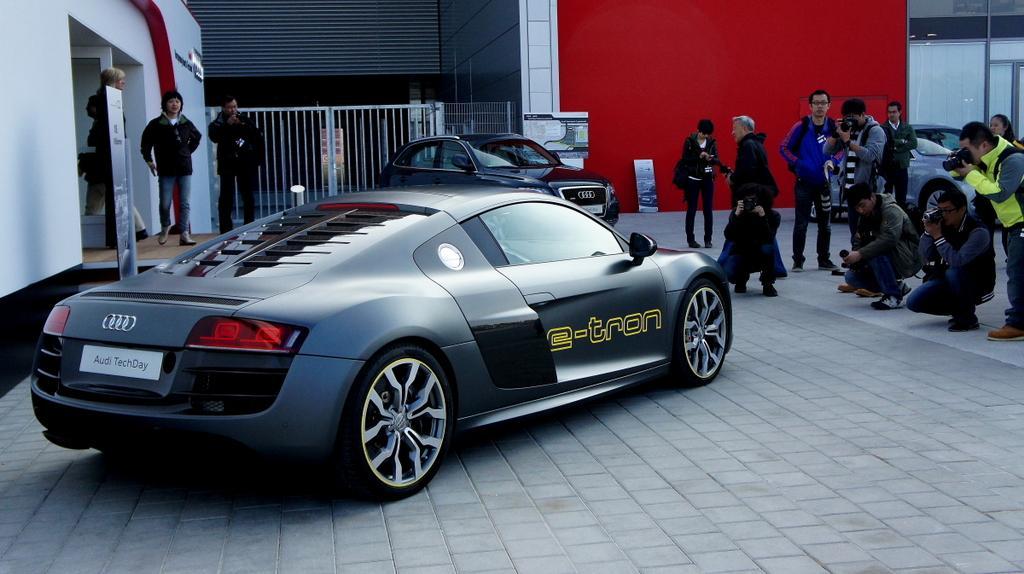In one or two sentences, can you explain what this image depicts? In this image we can see motor vehicles on the floor. In the background we can see walls, grill, persons around. 